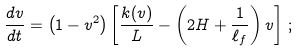<formula> <loc_0><loc_0><loc_500><loc_500>\frac { d v } { d t } = \left ( 1 - { v ^ { 2 } } \right ) \left [ \frac { k ( v ) } { L } - \left ( 2 H + \frac { 1 } { \ell _ { f } } \right ) v \right ] \, ;</formula> 